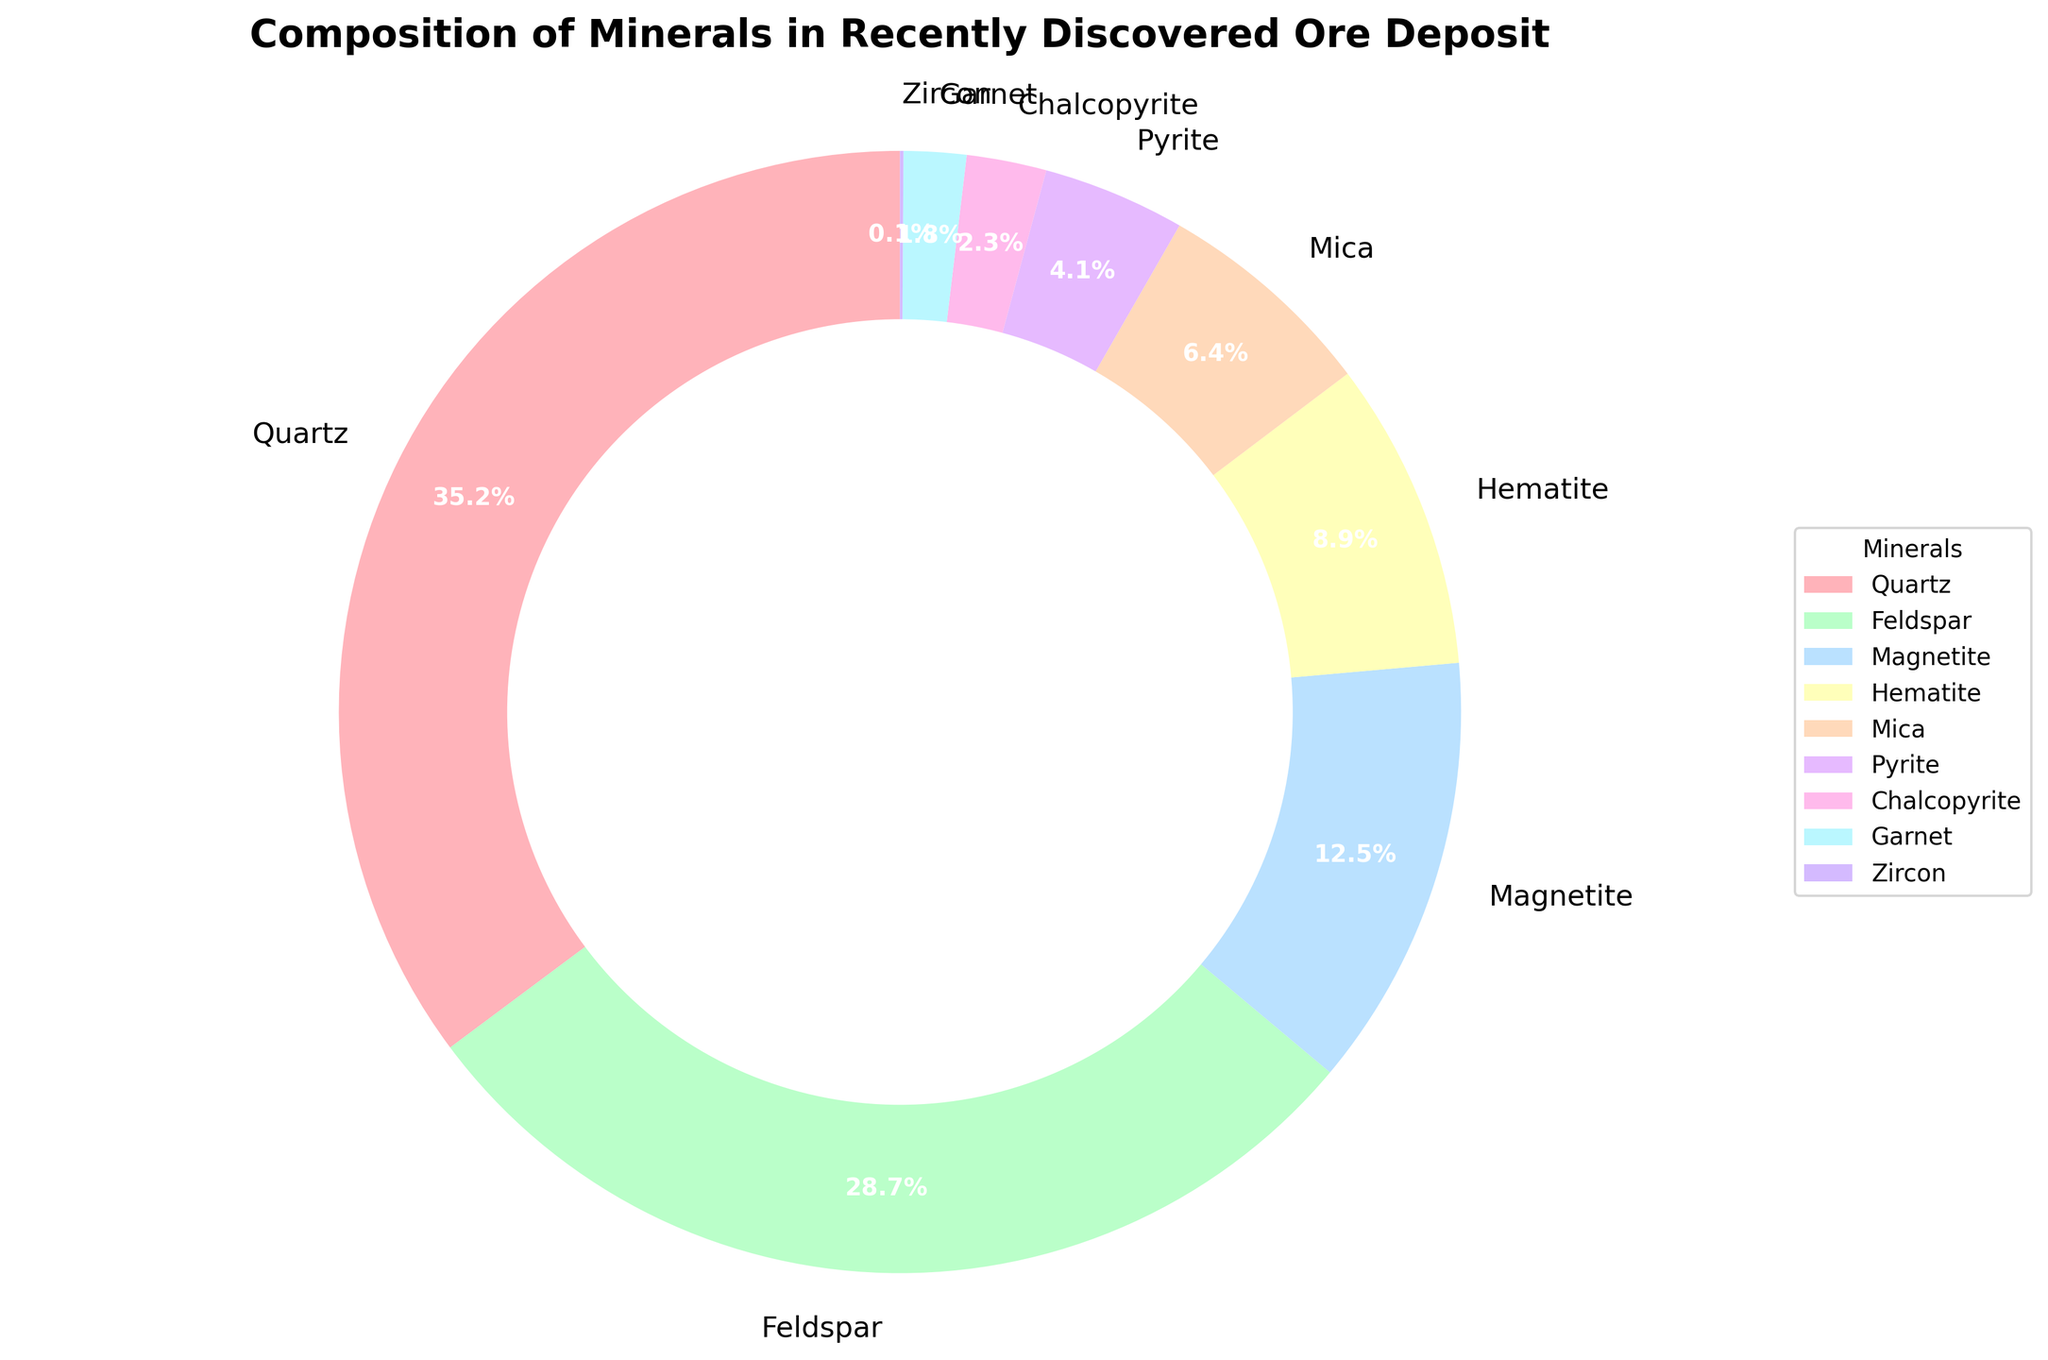What percentage of the ore deposit is made up of Quartz and Feldspar combined? To find the combined percentage, sum the individual percentages of Quartz and Feldspar. Quartz contributes 35.2% and Feldspar 28.7%. Sum these to get 35.2 + 28.7 = 63.9%.
Answer: 63.9% Which mineral has the smallest proportion, and what is its percentage? The smallest proportion is identified by locating the smallest percentage on the pie chart. Zircon has the smallest slice and contributes 0.1%.
Answer: Zircon, 0.1% What is the difference in percentage between Magnetite and Hematite? Subtract the percentage of Hematite from that of Magnetite. Magnetite is 12.5% and Hematite is 8.9%. The difference is 12.5 - 8.9 = 3.6%.
Answer: 3.6% Which minerals make up less than 5% of the ore deposit? Identify the minerals with slices representing less than 5% each on the pie chart. Pyrite (4.1%), Chalcopyrite (2.3%), Garnet (1.8%), and Zircon (0.1%) fit this criterion.
Answer: Pyrite, Chalcopyrite, Garnet, Zircon Is the proportion of Mica greater than that of Chalcopyrite and Garnet combined? Compare Mica's percentage with the combined percentage of Chalcopyrite and Garnet. Mica is 6.4%, Chalcopyrite and Garnet together are 2.3% + 1.8% = 4.1%. Since 6.4% is greater than 4.1%, Mica's proportion is indeed greater.
Answer: Yes What is the total proportion of the minerals that contribute more than 10% individually? Sum the percentages of Quartz, Feldspar, and Magnetite, which each contribute more than 10%. The calculation is 35.2% + 28.7% + 12.5% = 76.4%.
Answer: 76.4% Is the combined percentage of Mica and Pyrite equal to or greater than that of Magnetite? Add Mica's 6.4% to Pyrite's 4.1% for a total of 10.5%, then compare this to Magnetite's 12.5%. Since 10.5% is less than 12.5%, the combined percentage is not greater.
Answer: No What colors represent Hematite and Chalcopyrite? Hematite is represented by one color, and Chalcopyrite by another. Identify them by matching the color slices on the pie chart. Hematite is represented by a brownish hue and Chalcopyrite by a pink hue.
Answer: Brownish and Pink Which mineral is represented by the largest slice of the pie chart? The largest slice indicates the mineral with the highest percentage. Quartz, making up 35.2%, has the largest slice on the chart.
Answer: Quartz 